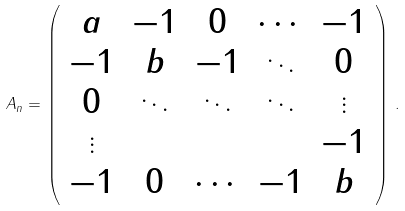<formula> <loc_0><loc_0><loc_500><loc_500>A _ { n } = \left ( \begin{array} { c c c c c } a & - 1 & 0 & \cdots & - 1 \\ - 1 & b & - 1 & \ddots & 0 \\ 0 & \ddots & \ddots & \ddots & \vdots \\ \vdots & & & & - 1 \\ - 1 & 0 & \cdots & - 1 & b \end{array} \right ) \, .</formula> 